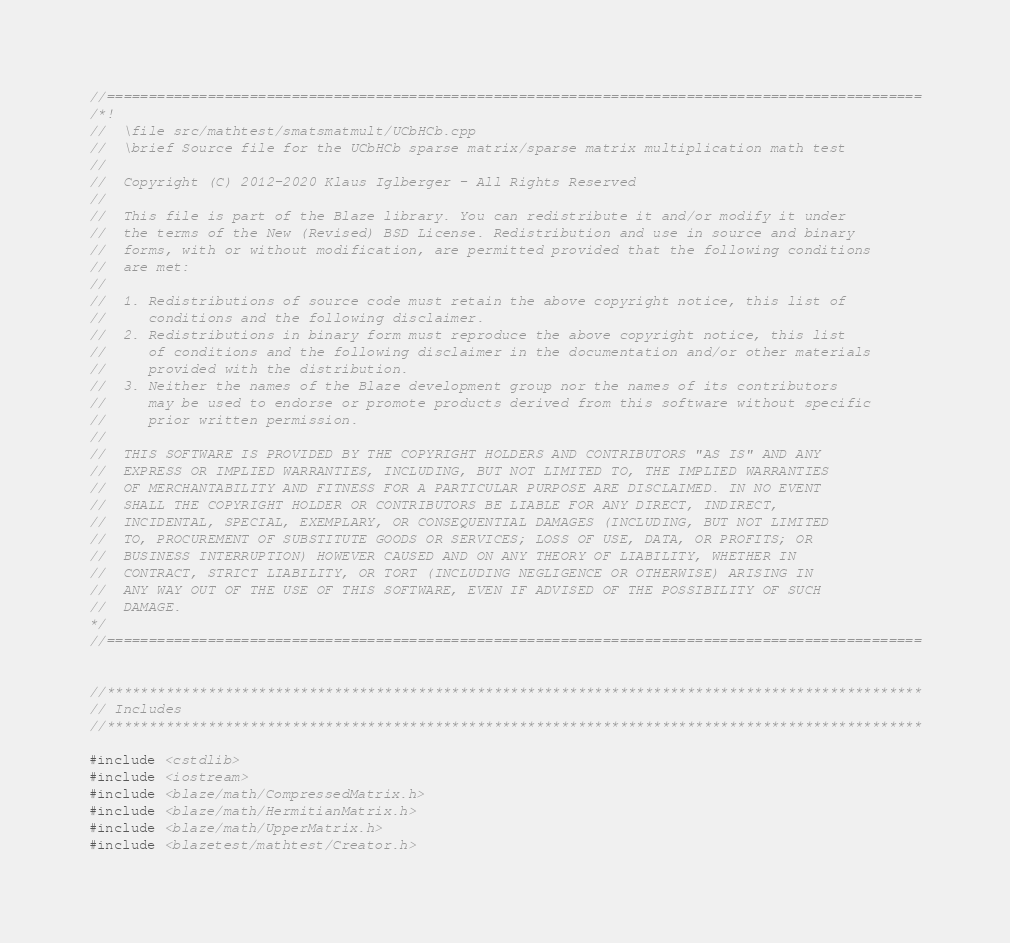<code> <loc_0><loc_0><loc_500><loc_500><_C++_>//=================================================================================================
/*!
//  \file src/mathtest/smatsmatmult/UCbHCb.cpp
//  \brief Source file for the UCbHCb sparse matrix/sparse matrix multiplication math test
//
//  Copyright (C) 2012-2020 Klaus Iglberger - All Rights Reserved
//
//  This file is part of the Blaze library. You can redistribute it and/or modify it under
//  the terms of the New (Revised) BSD License. Redistribution and use in source and binary
//  forms, with or without modification, are permitted provided that the following conditions
//  are met:
//
//  1. Redistributions of source code must retain the above copyright notice, this list of
//     conditions and the following disclaimer.
//  2. Redistributions in binary form must reproduce the above copyright notice, this list
//     of conditions and the following disclaimer in the documentation and/or other materials
//     provided with the distribution.
//  3. Neither the names of the Blaze development group nor the names of its contributors
//     may be used to endorse or promote products derived from this software without specific
//     prior written permission.
//
//  THIS SOFTWARE IS PROVIDED BY THE COPYRIGHT HOLDERS AND CONTRIBUTORS "AS IS" AND ANY
//  EXPRESS OR IMPLIED WARRANTIES, INCLUDING, BUT NOT LIMITED TO, THE IMPLIED WARRANTIES
//  OF MERCHANTABILITY AND FITNESS FOR A PARTICULAR PURPOSE ARE DISCLAIMED. IN NO EVENT
//  SHALL THE COPYRIGHT HOLDER OR CONTRIBUTORS BE LIABLE FOR ANY DIRECT, INDIRECT,
//  INCIDENTAL, SPECIAL, EXEMPLARY, OR CONSEQUENTIAL DAMAGES (INCLUDING, BUT NOT LIMITED
//  TO, PROCUREMENT OF SUBSTITUTE GOODS OR SERVICES; LOSS OF USE, DATA, OR PROFITS; OR
//  BUSINESS INTERRUPTION) HOWEVER CAUSED AND ON ANY THEORY OF LIABILITY, WHETHER IN
//  CONTRACT, STRICT LIABILITY, OR TORT (INCLUDING NEGLIGENCE OR OTHERWISE) ARISING IN
//  ANY WAY OUT OF THE USE OF THIS SOFTWARE, EVEN IF ADVISED OF THE POSSIBILITY OF SUCH
//  DAMAGE.
*/
//=================================================================================================


//*************************************************************************************************
// Includes
//*************************************************************************************************

#include <cstdlib>
#include <iostream>
#include <blaze/math/CompressedMatrix.h>
#include <blaze/math/HermitianMatrix.h>
#include <blaze/math/UpperMatrix.h>
#include <blazetest/mathtest/Creator.h></code> 